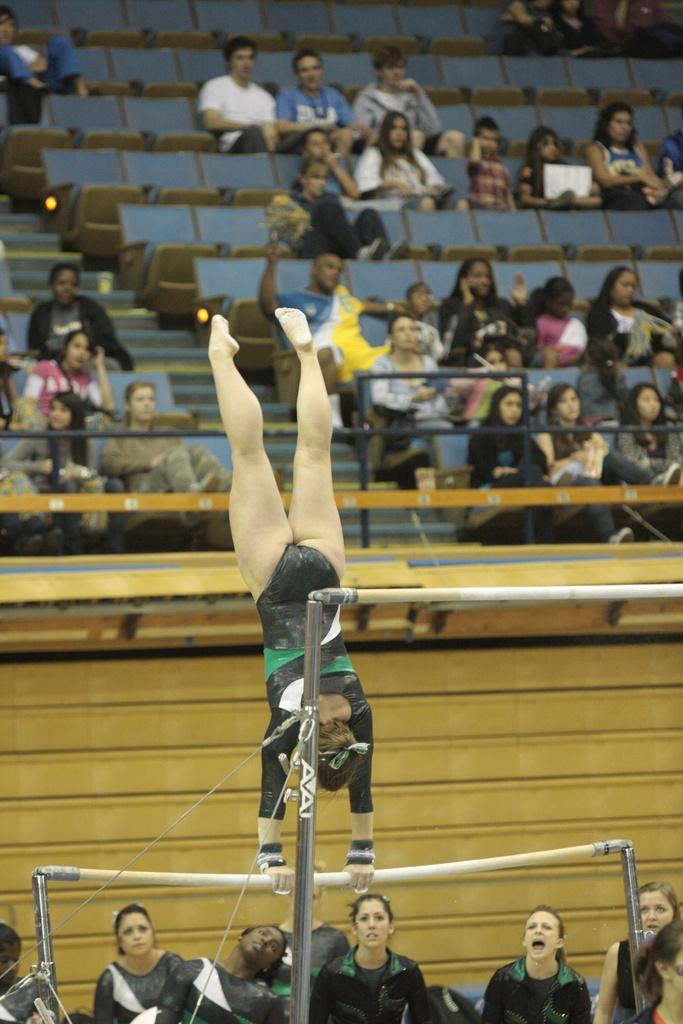<image>
Give a short and clear explanation of the subsequent image. a gymnast on unparalleled bars that are made by AVAI 